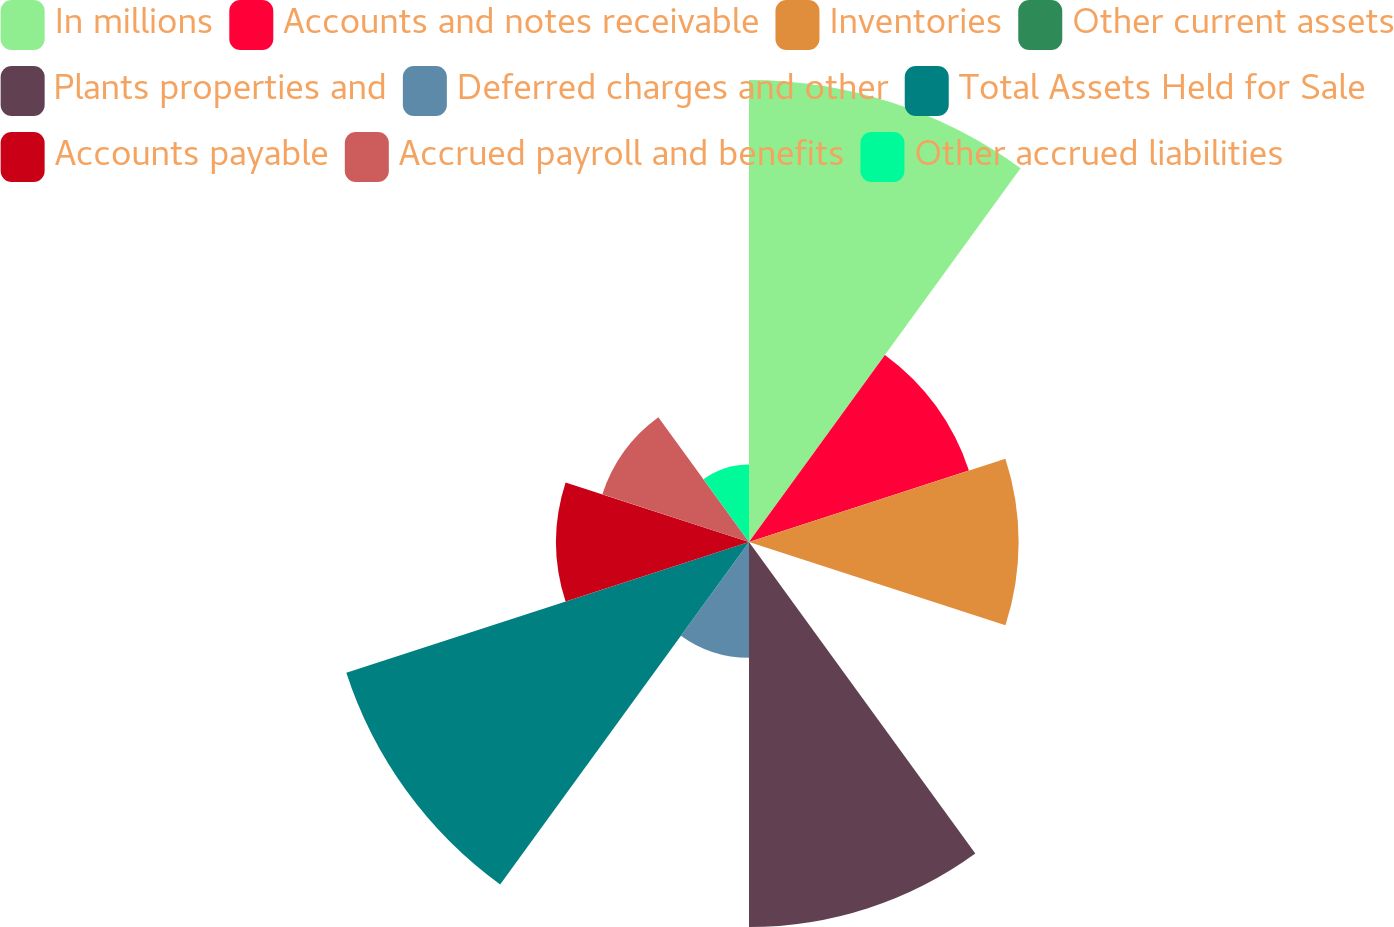Convert chart to OTSL. <chart><loc_0><loc_0><loc_500><loc_500><pie_chart><fcel>In millions<fcel>Accounts and notes receivable<fcel>Inventories<fcel>Other current assets<fcel>Plants properties and<fcel>Deferred charges and other<fcel>Total Assets Held for Sale<fcel>Accounts payable<fcel>Accrued payroll and benefits<fcel>Other accrued liabilities<nl><fcel>19.98%<fcel>10.0%<fcel>11.66%<fcel>0.02%<fcel>16.65%<fcel>5.01%<fcel>18.31%<fcel>8.34%<fcel>6.67%<fcel>3.35%<nl></chart> 